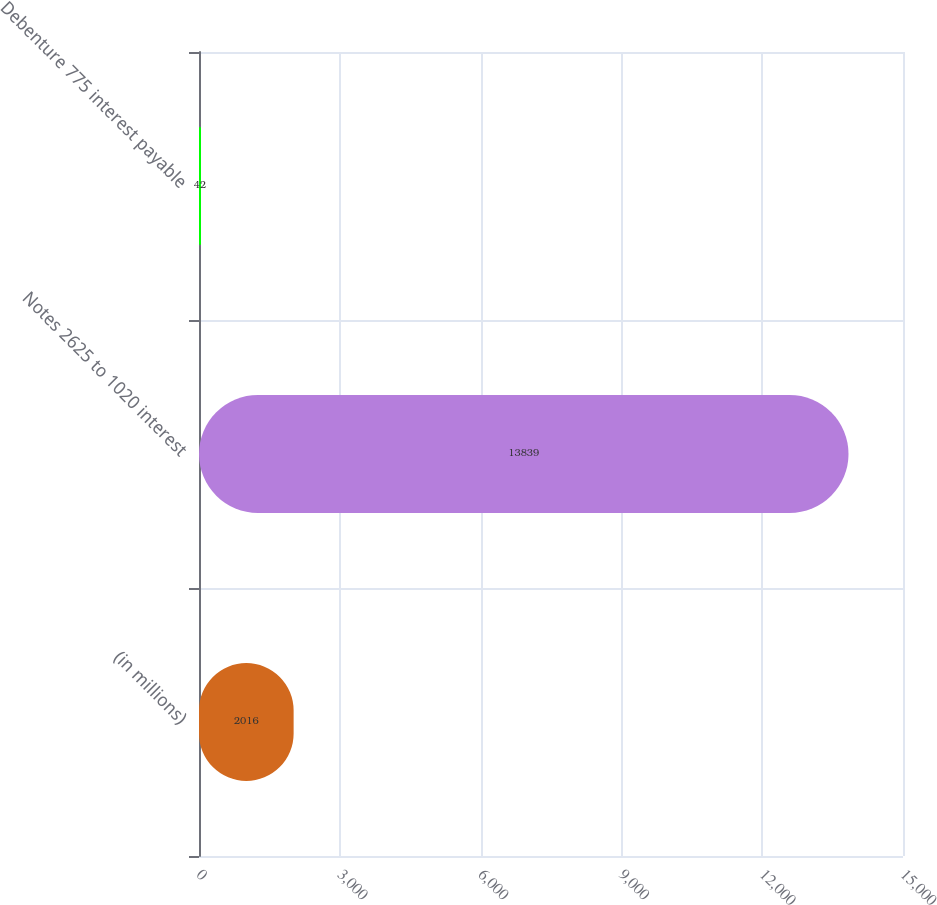Convert chart. <chart><loc_0><loc_0><loc_500><loc_500><bar_chart><fcel>(in millions)<fcel>Notes 2625 to 1020 interest<fcel>Debenture 775 interest payable<nl><fcel>2016<fcel>13839<fcel>42<nl></chart> 